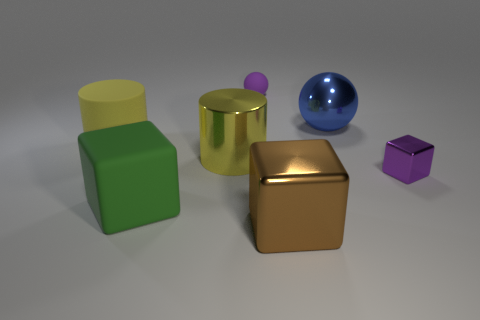What material is the tiny cube?
Your answer should be very brief. Metal. There is a metal object on the left side of the purple rubber ball; is it the same size as the small rubber sphere?
Keep it short and to the point. No. What number of objects are brown shiny blocks or small metallic cubes?
Provide a succinct answer. 2. The matte thing that is the same color as the shiny cylinder is what shape?
Ensure brevity in your answer.  Cylinder. There is a rubber thing that is on the right side of the big yellow rubber cylinder and in front of the large blue ball; what is its size?
Your response must be concise. Large. How many tiny green cubes are there?
Ensure brevity in your answer.  0. What number of blocks are either purple shiny objects or metal objects?
Your answer should be compact. 2. How many yellow rubber cylinders are behind the tiny object that is left of the tiny thing on the right side of the purple rubber ball?
Your answer should be compact. 0. There is a metal cylinder that is the same size as the brown cube; what color is it?
Your answer should be very brief. Yellow. How many other things are there of the same color as the matte cylinder?
Offer a terse response. 1. 